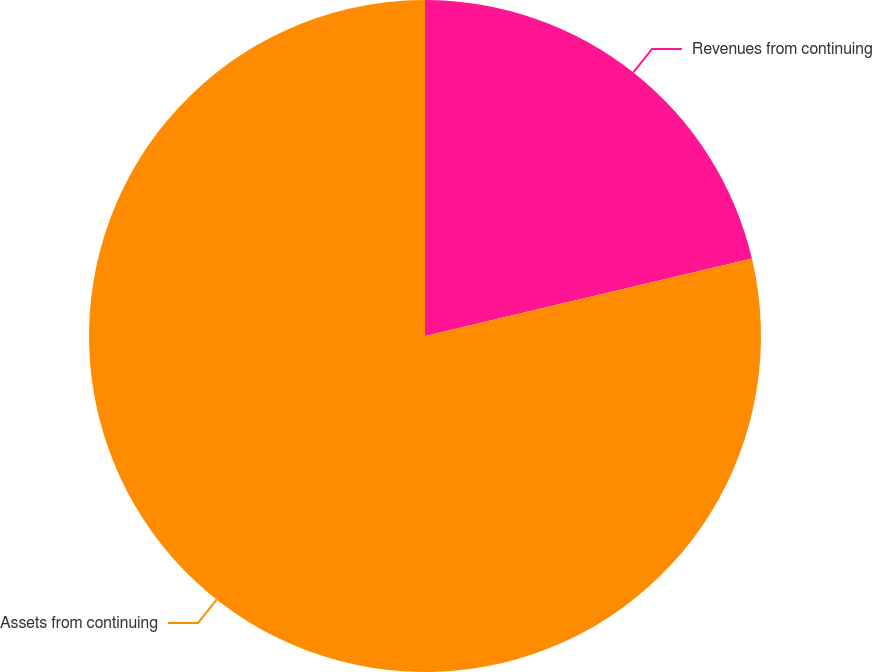Convert chart to OTSL. <chart><loc_0><loc_0><loc_500><loc_500><pie_chart><fcel>Revenues from continuing<fcel>Assets from continuing<nl><fcel>21.3%<fcel>78.7%<nl></chart> 